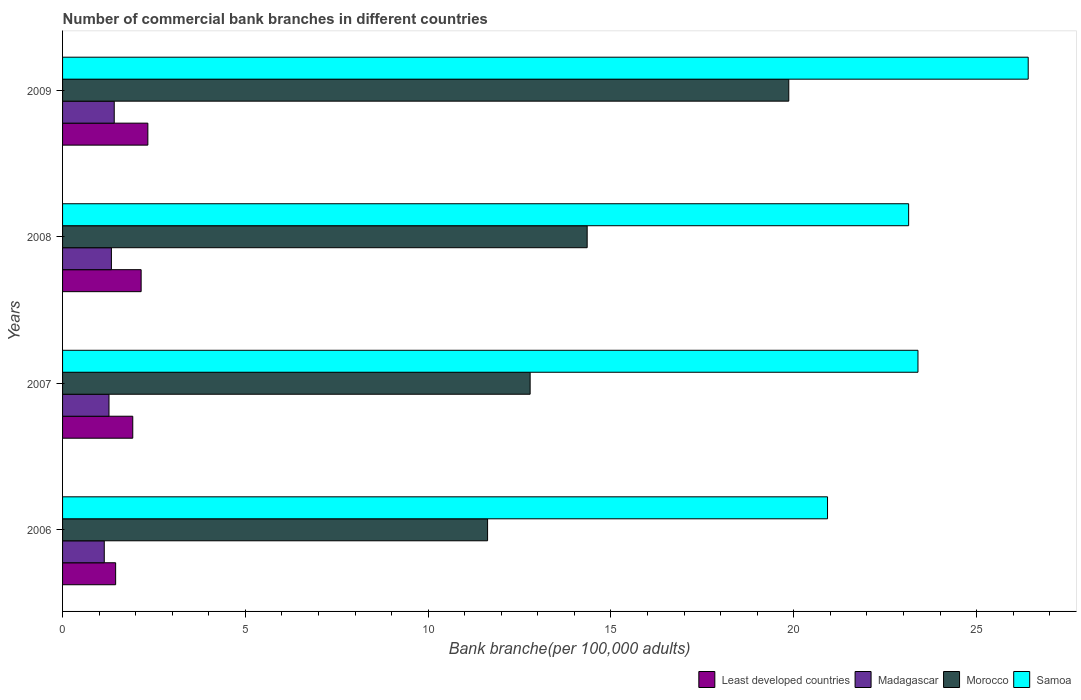How many groups of bars are there?
Your response must be concise. 4. Are the number of bars per tick equal to the number of legend labels?
Provide a succinct answer. Yes. What is the label of the 1st group of bars from the top?
Ensure brevity in your answer.  2009. What is the number of commercial bank branches in Madagascar in 2007?
Provide a short and direct response. 1.27. Across all years, what is the maximum number of commercial bank branches in Morocco?
Your answer should be very brief. 19.86. Across all years, what is the minimum number of commercial bank branches in Madagascar?
Keep it short and to the point. 1.14. What is the total number of commercial bank branches in Samoa in the graph?
Your answer should be very brief. 93.88. What is the difference between the number of commercial bank branches in Least developed countries in 2007 and that in 2008?
Offer a very short reply. -0.23. What is the difference between the number of commercial bank branches in Least developed countries in 2008 and the number of commercial bank branches in Madagascar in 2007?
Make the answer very short. 0.88. What is the average number of commercial bank branches in Morocco per year?
Keep it short and to the point. 14.66. In the year 2008, what is the difference between the number of commercial bank branches in Madagascar and number of commercial bank branches in Least developed countries?
Offer a very short reply. -0.81. What is the ratio of the number of commercial bank branches in Samoa in 2006 to that in 2008?
Your answer should be compact. 0.9. Is the number of commercial bank branches in Madagascar in 2006 less than that in 2008?
Offer a very short reply. Yes. Is the difference between the number of commercial bank branches in Madagascar in 2007 and 2008 greater than the difference between the number of commercial bank branches in Least developed countries in 2007 and 2008?
Give a very brief answer. Yes. What is the difference between the highest and the second highest number of commercial bank branches in Least developed countries?
Your answer should be very brief. 0.18. What is the difference between the highest and the lowest number of commercial bank branches in Samoa?
Your response must be concise. 5.49. Is the sum of the number of commercial bank branches in Morocco in 2006 and 2007 greater than the maximum number of commercial bank branches in Least developed countries across all years?
Make the answer very short. Yes. Is it the case that in every year, the sum of the number of commercial bank branches in Morocco and number of commercial bank branches in Least developed countries is greater than the sum of number of commercial bank branches in Madagascar and number of commercial bank branches in Samoa?
Your response must be concise. Yes. What does the 1st bar from the top in 2008 represents?
Your answer should be compact. Samoa. What does the 3rd bar from the bottom in 2009 represents?
Keep it short and to the point. Morocco. How many bars are there?
Keep it short and to the point. 16. What is the difference between two consecutive major ticks on the X-axis?
Keep it short and to the point. 5. Are the values on the major ticks of X-axis written in scientific E-notation?
Provide a short and direct response. No. Does the graph contain any zero values?
Your answer should be very brief. No. Does the graph contain grids?
Your answer should be very brief. No. Where does the legend appear in the graph?
Provide a succinct answer. Bottom right. What is the title of the graph?
Offer a very short reply. Number of commercial bank branches in different countries. What is the label or title of the X-axis?
Keep it short and to the point. Bank branche(per 100,0 adults). What is the Bank branche(per 100,000 adults) in Least developed countries in 2006?
Make the answer very short. 1.45. What is the Bank branche(per 100,000 adults) of Madagascar in 2006?
Make the answer very short. 1.14. What is the Bank branche(per 100,000 adults) of Morocco in 2006?
Offer a terse response. 11.63. What is the Bank branche(per 100,000 adults) of Samoa in 2006?
Provide a short and direct response. 20.92. What is the Bank branche(per 100,000 adults) of Least developed countries in 2007?
Ensure brevity in your answer.  1.92. What is the Bank branche(per 100,000 adults) of Madagascar in 2007?
Keep it short and to the point. 1.27. What is the Bank branche(per 100,000 adults) of Morocco in 2007?
Keep it short and to the point. 12.79. What is the Bank branche(per 100,000 adults) in Samoa in 2007?
Make the answer very short. 23.4. What is the Bank branche(per 100,000 adults) in Least developed countries in 2008?
Keep it short and to the point. 2.15. What is the Bank branche(per 100,000 adults) of Madagascar in 2008?
Offer a very short reply. 1.34. What is the Bank branche(per 100,000 adults) in Morocco in 2008?
Offer a terse response. 14.35. What is the Bank branche(per 100,000 adults) in Samoa in 2008?
Ensure brevity in your answer.  23.14. What is the Bank branche(per 100,000 adults) in Least developed countries in 2009?
Your response must be concise. 2.33. What is the Bank branche(per 100,000 adults) of Madagascar in 2009?
Offer a terse response. 1.41. What is the Bank branche(per 100,000 adults) in Morocco in 2009?
Ensure brevity in your answer.  19.86. What is the Bank branche(per 100,000 adults) in Samoa in 2009?
Your response must be concise. 26.41. Across all years, what is the maximum Bank branche(per 100,000 adults) in Least developed countries?
Provide a succinct answer. 2.33. Across all years, what is the maximum Bank branche(per 100,000 adults) in Madagascar?
Provide a succinct answer. 1.41. Across all years, what is the maximum Bank branche(per 100,000 adults) of Morocco?
Offer a terse response. 19.86. Across all years, what is the maximum Bank branche(per 100,000 adults) in Samoa?
Keep it short and to the point. 26.41. Across all years, what is the minimum Bank branche(per 100,000 adults) of Least developed countries?
Keep it short and to the point. 1.45. Across all years, what is the minimum Bank branche(per 100,000 adults) in Madagascar?
Offer a terse response. 1.14. Across all years, what is the minimum Bank branche(per 100,000 adults) in Morocco?
Your answer should be compact. 11.63. Across all years, what is the minimum Bank branche(per 100,000 adults) of Samoa?
Provide a short and direct response. 20.92. What is the total Bank branche(per 100,000 adults) in Least developed countries in the graph?
Your answer should be very brief. 7.85. What is the total Bank branche(per 100,000 adults) in Madagascar in the graph?
Provide a short and direct response. 5.16. What is the total Bank branche(per 100,000 adults) in Morocco in the graph?
Your answer should be compact. 58.63. What is the total Bank branche(per 100,000 adults) in Samoa in the graph?
Your response must be concise. 93.88. What is the difference between the Bank branche(per 100,000 adults) of Least developed countries in 2006 and that in 2007?
Make the answer very short. -0.47. What is the difference between the Bank branche(per 100,000 adults) of Madagascar in 2006 and that in 2007?
Provide a short and direct response. -0.13. What is the difference between the Bank branche(per 100,000 adults) in Morocco in 2006 and that in 2007?
Keep it short and to the point. -1.16. What is the difference between the Bank branche(per 100,000 adults) of Samoa in 2006 and that in 2007?
Offer a terse response. -2.47. What is the difference between the Bank branche(per 100,000 adults) of Least developed countries in 2006 and that in 2008?
Offer a very short reply. -0.7. What is the difference between the Bank branche(per 100,000 adults) of Madagascar in 2006 and that in 2008?
Provide a short and direct response. -0.2. What is the difference between the Bank branche(per 100,000 adults) in Morocco in 2006 and that in 2008?
Offer a terse response. -2.72. What is the difference between the Bank branche(per 100,000 adults) in Samoa in 2006 and that in 2008?
Your answer should be compact. -2.22. What is the difference between the Bank branche(per 100,000 adults) in Least developed countries in 2006 and that in 2009?
Offer a terse response. -0.88. What is the difference between the Bank branche(per 100,000 adults) in Madagascar in 2006 and that in 2009?
Provide a succinct answer. -0.27. What is the difference between the Bank branche(per 100,000 adults) of Morocco in 2006 and that in 2009?
Give a very brief answer. -8.24. What is the difference between the Bank branche(per 100,000 adults) of Samoa in 2006 and that in 2009?
Your answer should be very brief. -5.49. What is the difference between the Bank branche(per 100,000 adults) of Least developed countries in 2007 and that in 2008?
Provide a succinct answer. -0.23. What is the difference between the Bank branche(per 100,000 adults) in Madagascar in 2007 and that in 2008?
Keep it short and to the point. -0.07. What is the difference between the Bank branche(per 100,000 adults) in Morocco in 2007 and that in 2008?
Provide a succinct answer. -1.56. What is the difference between the Bank branche(per 100,000 adults) in Samoa in 2007 and that in 2008?
Offer a very short reply. 0.26. What is the difference between the Bank branche(per 100,000 adults) in Least developed countries in 2007 and that in 2009?
Ensure brevity in your answer.  -0.41. What is the difference between the Bank branche(per 100,000 adults) of Madagascar in 2007 and that in 2009?
Your answer should be compact. -0.14. What is the difference between the Bank branche(per 100,000 adults) in Morocco in 2007 and that in 2009?
Give a very brief answer. -7.07. What is the difference between the Bank branche(per 100,000 adults) in Samoa in 2007 and that in 2009?
Offer a terse response. -3.02. What is the difference between the Bank branche(per 100,000 adults) in Least developed countries in 2008 and that in 2009?
Your response must be concise. -0.18. What is the difference between the Bank branche(per 100,000 adults) in Madagascar in 2008 and that in 2009?
Keep it short and to the point. -0.08. What is the difference between the Bank branche(per 100,000 adults) of Morocco in 2008 and that in 2009?
Your response must be concise. -5.51. What is the difference between the Bank branche(per 100,000 adults) of Samoa in 2008 and that in 2009?
Provide a succinct answer. -3.27. What is the difference between the Bank branche(per 100,000 adults) of Least developed countries in 2006 and the Bank branche(per 100,000 adults) of Madagascar in 2007?
Your answer should be very brief. 0.18. What is the difference between the Bank branche(per 100,000 adults) in Least developed countries in 2006 and the Bank branche(per 100,000 adults) in Morocco in 2007?
Provide a short and direct response. -11.34. What is the difference between the Bank branche(per 100,000 adults) of Least developed countries in 2006 and the Bank branche(per 100,000 adults) of Samoa in 2007?
Your answer should be very brief. -21.95. What is the difference between the Bank branche(per 100,000 adults) of Madagascar in 2006 and the Bank branche(per 100,000 adults) of Morocco in 2007?
Make the answer very short. -11.65. What is the difference between the Bank branche(per 100,000 adults) of Madagascar in 2006 and the Bank branche(per 100,000 adults) of Samoa in 2007?
Provide a succinct answer. -22.26. What is the difference between the Bank branche(per 100,000 adults) in Morocco in 2006 and the Bank branche(per 100,000 adults) in Samoa in 2007?
Your answer should be very brief. -11.77. What is the difference between the Bank branche(per 100,000 adults) of Least developed countries in 2006 and the Bank branche(per 100,000 adults) of Madagascar in 2008?
Keep it short and to the point. 0.12. What is the difference between the Bank branche(per 100,000 adults) of Least developed countries in 2006 and the Bank branche(per 100,000 adults) of Morocco in 2008?
Your answer should be very brief. -12.9. What is the difference between the Bank branche(per 100,000 adults) of Least developed countries in 2006 and the Bank branche(per 100,000 adults) of Samoa in 2008?
Provide a succinct answer. -21.69. What is the difference between the Bank branche(per 100,000 adults) of Madagascar in 2006 and the Bank branche(per 100,000 adults) of Morocco in 2008?
Your answer should be very brief. -13.21. What is the difference between the Bank branche(per 100,000 adults) in Madagascar in 2006 and the Bank branche(per 100,000 adults) in Samoa in 2008?
Your answer should be compact. -22. What is the difference between the Bank branche(per 100,000 adults) in Morocco in 2006 and the Bank branche(per 100,000 adults) in Samoa in 2008?
Give a very brief answer. -11.52. What is the difference between the Bank branche(per 100,000 adults) of Least developed countries in 2006 and the Bank branche(per 100,000 adults) of Madagascar in 2009?
Provide a succinct answer. 0.04. What is the difference between the Bank branche(per 100,000 adults) in Least developed countries in 2006 and the Bank branche(per 100,000 adults) in Morocco in 2009?
Your response must be concise. -18.41. What is the difference between the Bank branche(per 100,000 adults) of Least developed countries in 2006 and the Bank branche(per 100,000 adults) of Samoa in 2009?
Ensure brevity in your answer.  -24.96. What is the difference between the Bank branche(per 100,000 adults) of Madagascar in 2006 and the Bank branche(per 100,000 adults) of Morocco in 2009?
Offer a terse response. -18.72. What is the difference between the Bank branche(per 100,000 adults) of Madagascar in 2006 and the Bank branche(per 100,000 adults) of Samoa in 2009?
Make the answer very short. -25.27. What is the difference between the Bank branche(per 100,000 adults) in Morocco in 2006 and the Bank branche(per 100,000 adults) in Samoa in 2009?
Your answer should be compact. -14.79. What is the difference between the Bank branche(per 100,000 adults) in Least developed countries in 2007 and the Bank branche(per 100,000 adults) in Madagascar in 2008?
Your answer should be compact. 0.58. What is the difference between the Bank branche(per 100,000 adults) in Least developed countries in 2007 and the Bank branche(per 100,000 adults) in Morocco in 2008?
Offer a very short reply. -12.43. What is the difference between the Bank branche(per 100,000 adults) in Least developed countries in 2007 and the Bank branche(per 100,000 adults) in Samoa in 2008?
Give a very brief answer. -21.22. What is the difference between the Bank branche(per 100,000 adults) in Madagascar in 2007 and the Bank branche(per 100,000 adults) in Morocco in 2008?
Ensure brevity in your answer.  -13.08. What is the difference between the Bank branche(per 100,000 adults) in Madagascar in 2007 and the Bank branche(per 100,000 adults) in Samoa in 2008?
Provide a succinct answer. -21.87. What is the difference between the Bank branche(per 100,000 adults) in Morocco in 2007 and the Bank branche(per 100,000 adults) in Samoa in 2008?
Offer a very short reply. -10.35. What is the difference between the Bank branche(per 100,000 adults) of Least developed countries in 2007 and the Bank branche(per 100,000 adults) of Madagascar in 2009?
Provide a short and direct response. 0.51. What is the difference between the Bank branche(per 100,000 adults) in Least developed countries in 2007 and the Bank branche(per 100,000 adults) in Morocco in 2009?
Provide a short and direct response. -17.94. What is the difference between the Bank branche(per 100,000 adults) of Least developed countries in 2007 and the Bank branche(per 100,000 adults) of Samoa in 2009?
Your answer should be compact. -24.49. What is the difference between the Bank branche(per 100,000 adults) of Madagascar in 2007 and the Bank branche(per 100,000 adults) of Morocco in 2009?
Your response must be concise. -18.59. What is the difference between the Bank branche(per 100,000 adults) of Madagascar in 2007 and the Bank branche(per 100,000 adults) of Samoa in 2009?
Offer a very short reply. -25.14. What is the difference between the Bank branche(per 100,000 adults) of Morocco in 2007 and the Bank branche(per 100,000 adults) of Samoa in 2009?
Keep it short and to the point. -13.62. What is the difference between the Bank branche(per 100,000 adults) in Least developed countries in 2008 and the Bank branche(per 100,000 adults) in Madagascar in 2009?
Ensure brevity in your answer.  0.74. What is the difference between the Bank branche(per 100,000 adults) in Least developed countries in 2008 and the Bank branche(per 100,000 adults) in Morocco in 2009?
Give a very brief answer. -17.71. What is the difference between the Bank branche(per 100,000 adults) of Least developed countries in 2008 and the Bank branche(per 100,000 adults) of Samoa in 2009?
Provide a short and direct response. -24.26. What is the difference between the Bank branche(per 100,000 adults) of Madagascar in 2008 and the Bank branche(per 100,000 adults) of Morocco in 2009?
Ensure brevity in your answer.  -18.53. What is the difference between the Bank branche(per 100,000 adults) in Madagascar in 2008 and the Bank branche(per 100,000 adults) in Samoa in 2009?
Provide a short and direct response. -25.08. What is the difference between the Bank branche(per 100,000 adults) in Morocco in 2008 and the Bank branche(per 100,000 adults) in Samoa in 2009?
Your answer should be compact. -12.06. What is the average Bank branche(per 100,000 adults) in Least developed countries per year?
Offer a terse response. 1.96. What is the average Bank branche(per 100,000 adults) in Madagascar per year?
Give a very brief answer. 1.29. What is the average Bank branche(per 100,000 adults) of Morocco per year?
Ensure brevity in your answer.  14.66. What is the average Bank branche(per 100,000 adults) of Samoa per year?
Give a very brief answer. 23.47. In the year 2006, what is the difference between the Bank branche(per 100,000 adults) of Least developed countries and Bank branche(per 100,000 adults) of Madagascar?
Make the answer very short. 0.31. In the year 2006, what is the difference between the Bank branche(per 100,000 adults) of Least developed countries and Bank branche(per 100,000 adults) of Morocco?
Make the answer very short. -10.17. In the year 2006, what is the difference between the Bank branche(per 100,000 adults) of Least developed countries and Bank branche(per 100,000 adults) of Samoa?
Give a very brief answer. -19.47. In the year 2006, what is the difference between the Bank branche(per 100,000 adults) in Madagascar and Bank branche(per 100,000 adults) in Morocco?
Give a very brief answer. -10.48. In the year 2006, what is the difference between the Bank branche(per 100,000 adults) of Madagascar and Bank branche(per 100,000 adults) of Samoa?
Ensure brevity in your answer.  -19.78. In the year 2006, what is the difference between the Bank branche(per 100,000 adults) of Morocco and Bank branche(per 100,000 adults) of Samoa?
Provide a short and direct response. -9.3. In the year 2007, what is the difference between the Bank branche(per 100,000 adults) of Least developed countries and Bank branche(per 100,000 adults) of Madagascar?
Keep it short and to the point. 0.65. In the year 2007, what is the difference between the Bank branche(per 100,000 adults) in Least developed countries and Bank branche(per 100,000 adults) in Morocco?
Ensure brevity in your answer.  -10.87. In the year 2007, what is the difference between the Bank branche(per 100,000 adults) of Least developed countries and Bank branche(per 100,000 adults) of Samoa?
Offer a very short reply. -21.48. In the year 2007, what is the difference between the Bank branche(per 100,000 adults) of Madagascar and Bank branche(per 100,000 adults) of Morocco?
Your response must be concise. -11.52. In the year 2007, what is the difference between the Bank branche(per 100,000 adults) of Madagascar and Bank branche(per 100,000 adults) of Samoa?
Make the answer very short. -22.13. In the year 2007, what is the difference between the Bank branche(per 100,000 adults) in Morocco and Bank branche(per 100,000 adults) in Samoa?
Make the answer very short. -10.61. In the year 2008, what is the difference between the Bank branche(per 100,000 adults) in Least developed countries and Bank branche(per 100,000 adults) in Madagascar?
Ensure brevity in your answer.  0.81. In the year 2008, what is the difference between the Bank branche(per 100,000 adults) of Least developed countries and Bank branche(per 100,000 adults) of Morocco?
Your answer should be compact. -12.2. In the year 2008, what is the difference between the Bank branche(per 100,000 adults) of Least developed countries and Bank branche(per 100,000 adults) of Samoa?
Your answer should be compact. -20.99. In the year 2008, what is the difference between the Bank branche(per 100,000 adults) in Madagascar and Bank branche(per 100,000 adults) in Morocco?
Offer a terse response. -13.01. In the year 2008, what is the difference between the Bank branche(per 100,000 adults) in Madagascar and Bank branche(per 100,000 adults) in Samoa?
Give a very brief answer. -21.81. In the year 2008, what is the difference between the Bank branche(per 100,000 adults) of Morocco and Bank branche(per 100,000 adults) of Samoa?
Offer a very short reply. -8.79. In the year 2009, what is the difference between the Bank branche(per 100,000 adults) in Least developed countries and Bank branche(per 100,000 adults) in Madagascar?
Offer a very short reply. 0.92. In the year 2009, what is the difference between the Bank branche(per 100,000 adults) of Least developed countries and Bank branche(per 100,000 adults) of Morocco?
Keep it short and to the point. -17.53. In the year 2009, what is the difference between the Bank branche(per 100,000 adults) in Least developed countries and Bank branche(per 100,000 adults) in Samoa?
Your answer should be compact. -24.08. In the year 2009, what is the difference between the Bank branche(per 100,000 adults) of Madagascar and Bank branche(per 100,000 adults) of Morocco?
Offer a very short reply. -18.45. In the year 2009, what is the difference between the Bank branche(per 100,000 adults) of Madagascar and Bank branche(per 100,000 adults) of Samoa?
Ensure brevity in your answer.  -25. In the year 2009, what is the difference between the Bank branche(per 100,000 adults) of Morocco and Bank branche(per 100,000 adults) of Samoa?
Your answer should be very brief. -6.55. What is the ratio of the Bank branche(per 100,000 adults) in Least developed countries in 2006 to that in 2007?
Your answer should be compact. 0.76. What is the ratio of the Bank branche(per 100,000 adults) of Madagascar in 2006 to that in 2007?
Offer a very short reply. 0.9. What is the ratio of the Bank branche(per 100,000 adults) in Morocco in 2006 to that in 2007?
Make the answer very short. 0.91. What is the ratio of the Bank branche(per 100,000 adults) of Samoa in 2006 to that in 2007?
Give a very brief answer. 0.89. What is the ratio of the Bank branche(per 100,000 adults) of Least developed countries in 2006 to that in 2008?
Your answer should be compact. 0.68. What is the ratio of the Bank branche(per 100,000 adults) in Madagascar in 2006 to that in 2008?
Ensure brevity in your answer.  0.85. What is the ratio of the Bank branche(per 100,000 adults) in Morocco in 2006 to that in 2008?
Your answer should be compact. 0.81. What is the ratio of the Bank branche(per 100,000 adults) of Samoa in 2006 to that in 2008?
Your answer should be very brief. 0.9. What is the ratio of the Bank branche(per 100,000 adults) in Least developed countries in 2006 to that in 2009?
Your answer should be compact. 0.62. What is the ratio of the Bank branche(per 100,000 adults) in Madagascar in 2006 to that in 2009?
Offer a very short reply. 0.81. What is the ratio of the Bank branche(per 100,000 adults) of Morocco in 2006 to that in 2009?
Provide a succinct answer. 0.59. What is the ratio of the Bank branche(per 100,000 adults) in Samoa in 2006 to that in 2009?
Offer a terse response. 0.79. What is the ratio of the Bank branche(per 100,000 adults) of Least developed countries in 2007 to that in 2008?
Provide a succinct answer. 0.89. What is the ratio of the Bank branche(per 100,000 adults) of Madagascar in 2007 to that in 2008?
Keep it short and to the point. 0.95. What is the ratio of the Bank branche(per 100,000 adults) in Morocco in 2007 to that in 2008?
Provide a short and direct response. 0.89. What is the ratio of the Bank branche(per 100,000 adults) of Samoa in 2007 to that in 2008?
Your answer should be compact. 1.01. What is the ratio of the Bank branche(per 100,000 adults) in Least developed countries in 2007 to that in 2009?
Ensure brevity in your answer.  0.82. What is the ratio of the Bank branche(per 100,000 adults) in Madagascar in 2007 to that in 2009?
Give a very brief answer. 0.9. What is the ratio of the Bank branche(per 100,000 adults) in Morocco in 2007 to that in 2009?
Your response must be concise. 0.64. What is the ratio of the Bank branche(per 100,000 adults) in Samoa in 2007 to that in 2009?
Provide a short and direct response. 0.89. What is the ratio of the Bank branche(per 100,000 adults) in Least developed countries in 2008 to that in 2009?
Your response must be concise. 0.92. What is the ratio of the Bank branche(per 100,000 adults) in Madagascar in 2008 to that in 2009?
Your answer should be very brief. 0.95. What is the ratio of the Bank branche(per 100,000 adults) in Morocco in 2008 to that in 2009?
Make the answer very short. 0.72. What is the ratio of the Bank branche(per 100,000 adults) of Samoa in 2008 to that in 2009?
Provide a succinct answer. 0.88. What is the difference between the highest and the second highest Bank branche(per 100,000 adults) in Least developed countries?
Provide a short and direct response. 0.18. What is the difference between the highest and the second highest Bank branche(per 100,000 adults) of Madagascar?
Keep it short and to the point. 0.08. What is the difference between the highest and the second highest Bank branche(per 100,000 adults) in Morocco?
Make the answer very short. 5.51. What is the difference between the highest and the second highest Bank branche(per 100,000 adults) in Samoa?
Provide a short and direct response. 3.02. What is the difference between the highest and the lowest Bank branche(per 100,000 adults) in Least developed countries?
Provide a succinct answer. 0.88. What is the difference between the highest and the lowest Bank branche(per 100,000 adults) in Madagascar?
Provide a succinct answer. 0.27. What is the difference between the highest and the lowest Bank branche(per 100,000 adults) of Morocco?
Ensure brevity in your answer.  8.24. What is the difference between the highest and the lowest Bank branche(per 100,000 adults) of Samoa?
Your response must be concise. 5.49. 